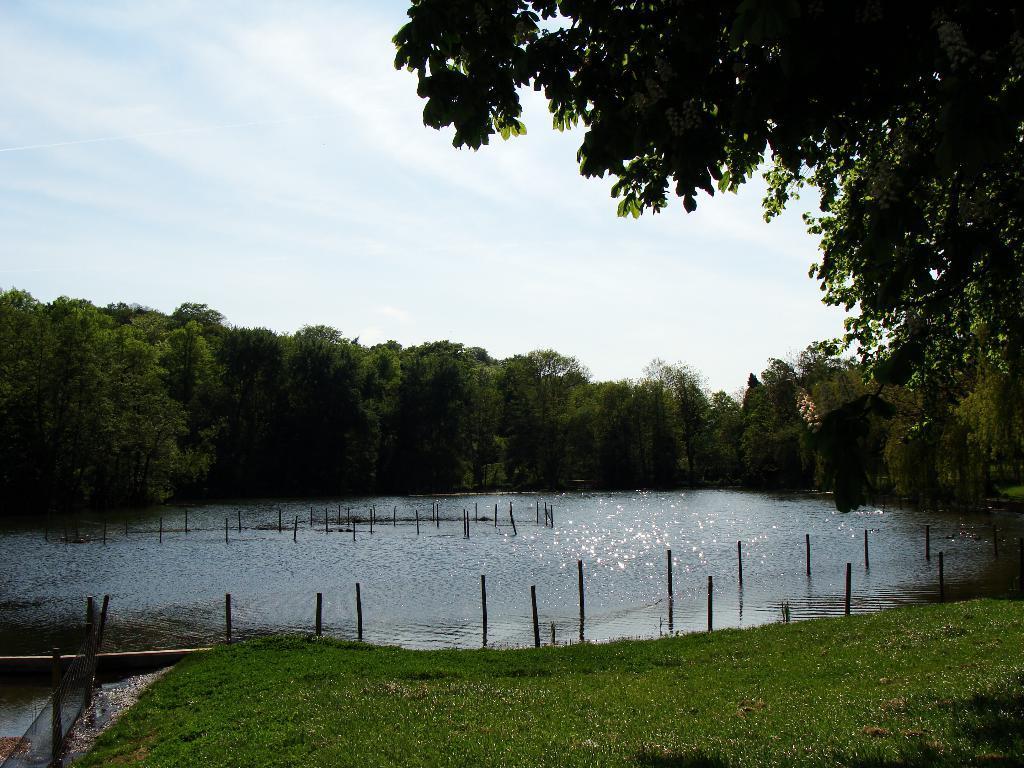Please provide a concise description of this image. In the image there is a grass in the foreground, behind the grass there is a water surface and in the background there are trees. 